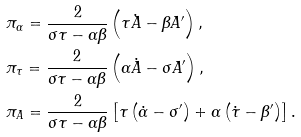Convert formula to latex. <formula><loc_0><loc_0><loc_500><loc_500>& \pi _ { \alpha } = \frac { 2 } { \sigma \tau - \alpha \beta } \left ( \tau { \dot { A } } - \beta A ^ { \prime } \right ) , \\ & \pi _ { \tau } = \frac { 2 } { \sigma \tau - \alpha \beta } \left ( \alpha { \dot { A } } - \sigma A ^ { \prime } \right ) , \\ & \pi _ { A } = \frac { 2 } { \sigma \tau - \alpha \beta } \left [ \tau \left ( { \dot { \alpha } } - \sigma ^ { \prime } \right ) + \alpha \left ( { \dot { \tau } } - \beta ^ { \prime } \right ) \right ] .</formula> 